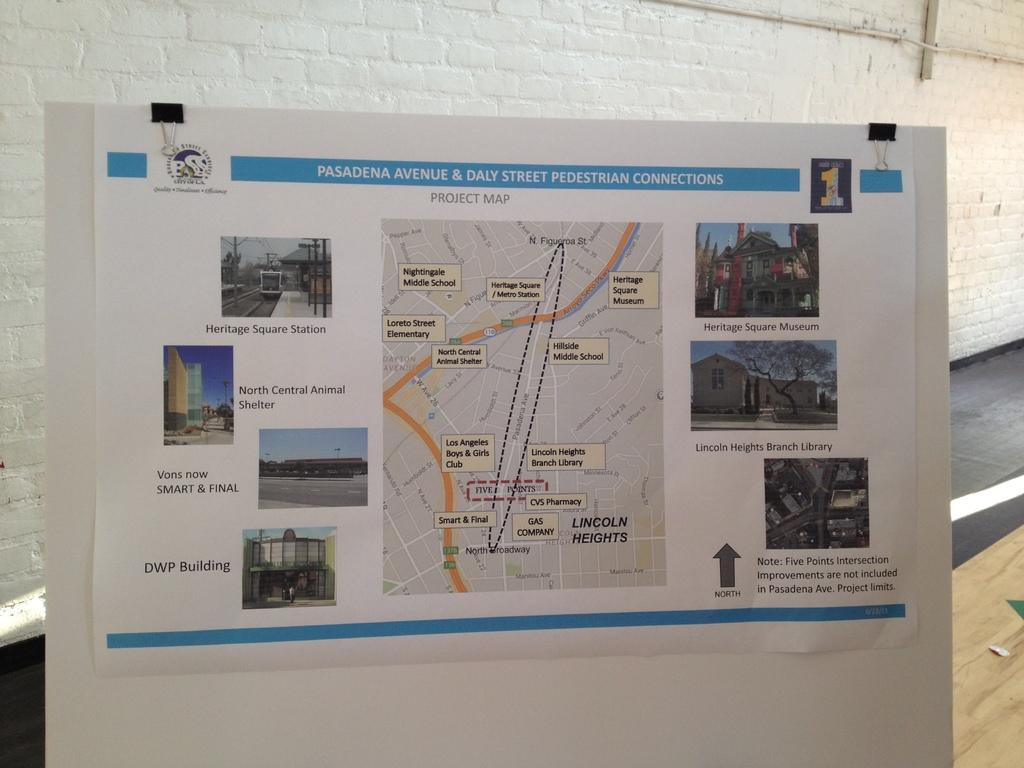What building is pictured in the bottom left?
Offer a terse response. Dwp building. 